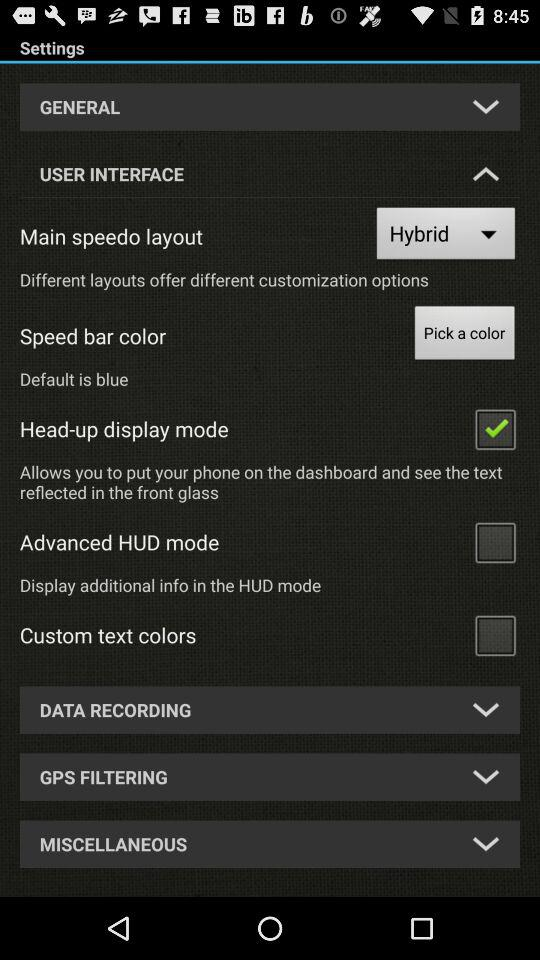What settings are checked? The checked setting is "Head-up display mode". 